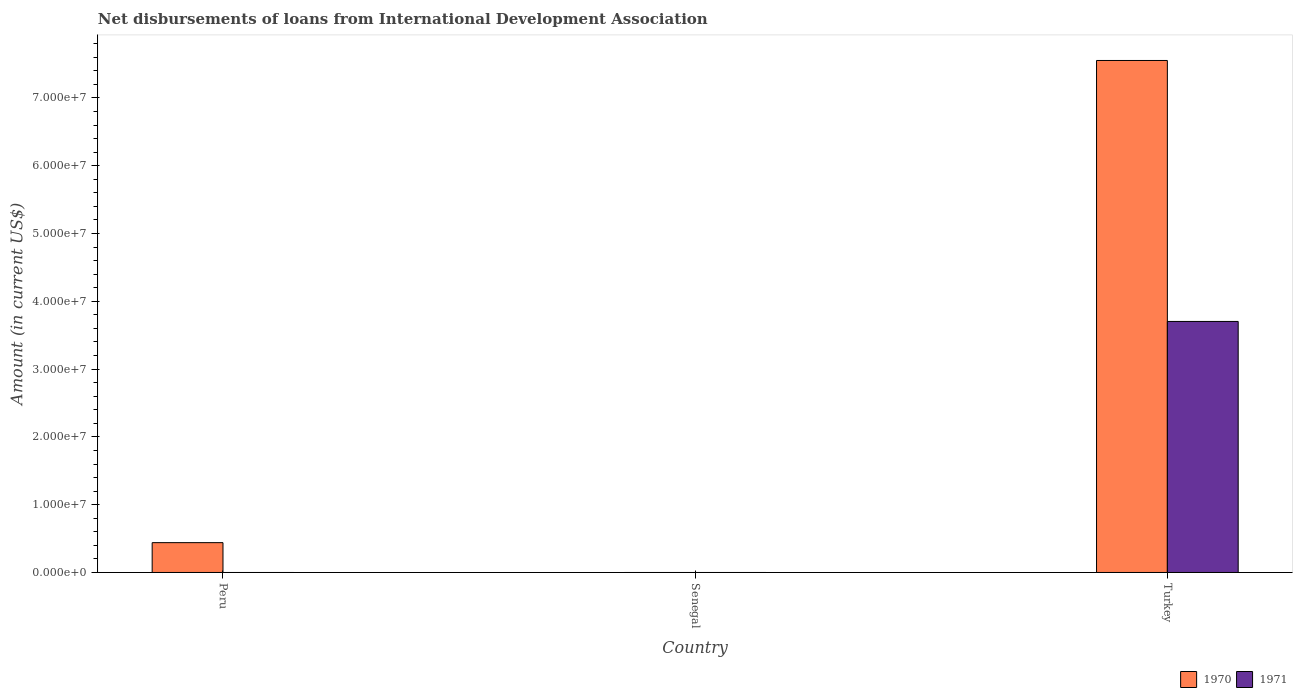How many different coloured bars are there?
Your answer should be compact. 2. Are the number of bars per tick equal to the number of legend labels?
Give a very brief answer. No. Are the number of bars on each tick of the X-axis equal?
Give a very brief answer. No. How many bars are there on the 3rd tick from the left?
Provide a short and direct response. 2. In how many cases, is the number of bars for a given country not equal to the number of legend labels?
Keep it short and to the point. 2. Across all countries, what is the maximum amount of loans disbursed in 1970?
Make the answer very short. 7.55e+07. Across all countries, what is the minimum amount of loans disbursed in 1971?
Keep it short and to the point. 0. In which country was the amount of loans disbursed in 1970 maximum?
Make the answer very short. Turkey. What is the total amount of loans disbursed in 1970 in the graph?
Offer a terse response. 7.99e+07. What is the difference between the amount of loans disbursed in 1970 in Peru and that in Turkey?
Make the answer very short. -7.11e+07. What is the difference between the amount of loans disbursed in 1971 in Senegal and the amount of loans disbursed in 1970 in Peru?
Provide a succinct answer. -4.40e+06. What is the average amount of loans disbursed in 1970 per country?
Give a very brief answer. 2.66e+07. What is the difference between the amount of loans disbursed of/in 1971 and amount of loans disbursed of/in 1970 in Turkey?
Provide a succinct answer. -3.85e+07. What is the ratio of the amount of loans disbursed in 1970 in Peru to that in Turkey?
Your answer should be compact. 0.06. What is the difference between the highest and the lowest amount of loans disbursed in 1971?
Ensure brevity in your answer.  3.70e+07. In how many countries, is the amount of loans disbursed in 1971 greater than the average amount of loans disbursed in 1971 taken over all countries?
Provide a short and direct response. 1. How many countries are there in the graph?
Provide a succinct answer. 3. Does the graph contain any zero values?
Make the answer very short. Yes. How many legend labels are there?
Give a very brief answer. 2. How are the legend labels stacked?
Your answer should be compact. Horizontal. What is the title of the graph?
Offer a very short reply. Net disbursements of loans from International Development Association. What is the Amount (in current US$) in 1970 in Peru?
Offer a terse response. 4.40e+06. What is the Amount (in current US$) of 1971 in Senegal?
Keep it short and to the point. 0. What is the Amount (in current US$) in 1970 in Turkey?
Keep it short and to the point. 7.55e+07. What is the Amount (in current US$) in 1971 in Turkey?
Keep it short and to the point. 3.70e+07. Across all countries, what is the maximum Amount (in current US$) of 1970?
Ensure brevity in your answer.  7.55e+07. Across all countries, what is the maximum Amount (in current US$) of 1971?
Offer a terse response. 3.70e+07. Across all countries, what is the minimum Amount (in current US$) of 1971?
Offer a very short reply. 0. What is the total Amount (in current US$) in 1970 in the graph?
Keep it short and to the point. 7.99e+07. What is the total Amount (in current US$) of 1971 in the graph?
Your answer should be very brief. 3.70e+07. What is the difference between the Amount (in current US$) of 1970 in Peru and that in Turkey?
Give a very brief answer. -7.11e+07. What is the difference between the Amount (in current US$) of 1970 in Peru and the Amount (in current US$) of 1971 in Turkey?
Your response must be concise. -3.26e+07. What is the average Amount (in current US$) of 1970 per country?
Ensure brevity in your answer.  2.66e+07. What is the average Amount (in current US$) of 1971 per country?
Ensure brevity in your answer.  1.23e+07. What is the difference between the Amount (in current US$) in 1970 and Amount (in current US$) in 1971 in Turkey?
Provide a short and direct response. 3.85e+07. What is the ratio of the Amount (in current US$) in 1970 in Peru to that in Turkey?
Provide a succinct answer. 0.06. What is the difference between the highest and the lowest Amount (in current US$) in 1970?
Offer a terse response. 7.55e+07. What is the difference between the highest and the lowest Amount (in current US$) in 1971?
Make the answer very short. 3.70e+07. 